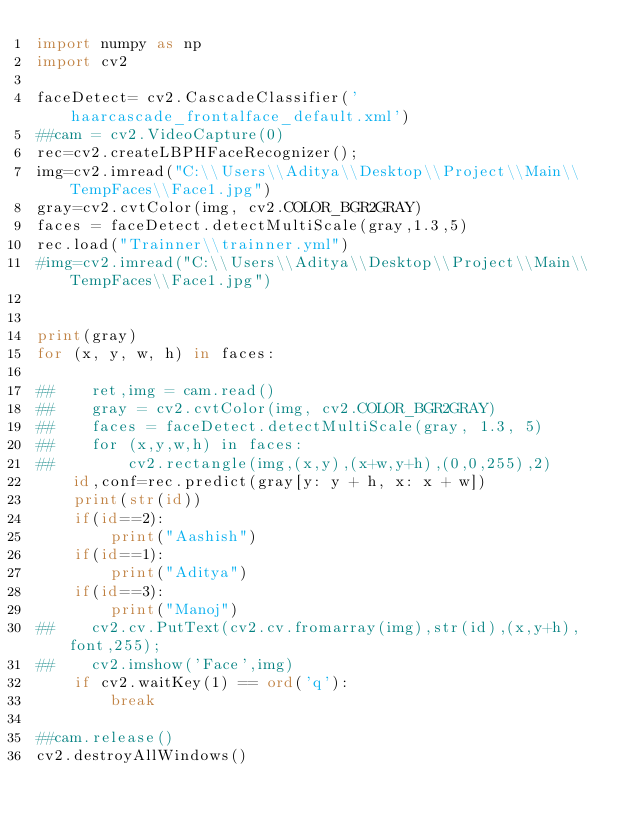Convert code to text. <code><loc_0><loc_0><loc_500><loc_500><_Python_>import numpy as np
import cv2

faceDetect= cv2.CascadeClassifier('haarcascade_frontalface_default.xml')
##cam = cv2.VideoCapture(0)
rec=cv2.createLBPHFaceRecognizer();
img=cv2.imread("C:\\Users\\Aditya\\Desktop\\Project\\Main\\TempFaces\\Face1.jpg")
gray=cv2.cvtColor(img, cv2.COLOR_BGR2GRAY)
faces = faceDetect.detectMultiScale(gray,1.3,5)
rec.load("Trainner\\trainner.yml")
#img=cv2.imread("C:\\Users\\Aditya\\Desktop\\Project\\Main\\TempFaces\\Face1.jpg")


print(gray)
for (x, y, w, h) in faces:
    
##    ret,img = cam.read()
##    gray = cv2.cvtColor(img, cv2.COLOR_BGR2GRAY)
##    faces = faceDetect.detectMultiScale(gray, 1.3, 5)
##    for (x,y,w,h) in faces:
##        cv2.rectangle(img,(x,y),(x+w,y+h),(0,0,255),2)
    id,conf=rec.predict(gray[y: y + h, x: x + w])
    print(str(id))
    if(id==2):
        print("Aashish")
    if(id==1):
        print("Aditya")
    if(id==3):
        print("Manoj")
##    cv2.cv.PutText(cv2.cv.fromarray(img),str(id),(x,y+h),font,255);
##    cv2.imshow('Face',img)
    if cv2.waitKey(1) == ord('q'):
        break
    
##cam.release()
cv2.destroyAllWindows()
</code> 